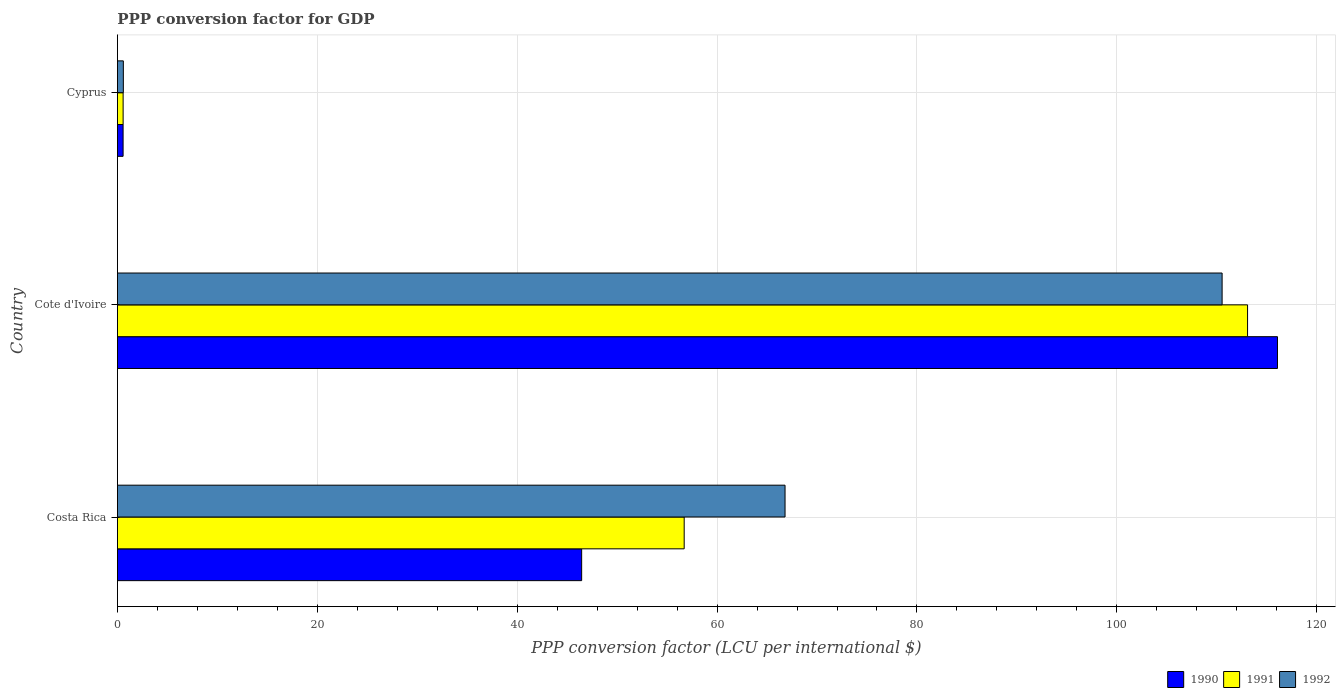Are the number of bars per tick equal to the number of legend labels?
Your answer should be very brief. Yes. How many bars are there on the 3rd tick from the top?
Keep it short and to the point. 3. How many bars are there on the 3rd tick from the bottom?
Your response must be concise. 3. What is the PPP conversion factor for GDP in 1990 in Cyprus?
Offer a terse response. 0.57. Across all countries, what is the maximum PPP conversion factor for GDP in 1992?
Ensure brevity in your answer.  110.53. Across all countries, what is the minimum PPP conversion factor for GDP in 1990?
Ensure brevity in your answer.  0.57. In which country was the PPP conversion factor for GDP in 1992 maximum?
Keep it short and to the point. Cote d'Ivoire. In which country was the PPP conversion factor for GDP in 1991 minimum?
Your answer should be very brief. Cyprus. What is the total PPP conversion factor for GDP in 1991 in the graph?
Offer a very short reply. 170.36. What is the difference between the PPP conversion factor for GDP in 1992 in Costa Rica and that in Cyprus?
Your answer should be compact. 66.21. What is the difference between the PPP conversion factor for GDP in 1991 in Cyprus and the PPP conversion factor for GDP in 1990 in Cote d'Ivoire?
Give a very brief answer. -115.5. What is the average PPP conversion factor for GDP in 1990 per country?
Keep it short and to the point. 54.36. What is the difference between the PPP conversion factor for GDP in 1992 and PPP conversion factor for GDP in 1991 in Cote d'Ivoire?
Make the answer very short. -2.55. What is the ratio of the PPP conversion factor for GDP in 1990 in Cote d'Ivoire to that in Cyprus?
Your answer should be very brief. 203.55. Is the PPP conversion factor for GDP in 1990 in Costa Rica less than that in Cyprus?
Your answer should be very brief. No. What is the difference between the highest and the second highest PPP conversion factor for GDP in 1991?
Your answer should be compact. 56.37. What is the difference between the highest and the lowest PPP conversion factor for GDP in 1992?
Make the answer very short. 109.94. Is the sum of the PPP conversion factor for GDP in 1991 in Cote d'Ivoire and Cyprus greater than the maximum PPP conversion factor for GDP in 1990 across all countries?
Your answer should be very brief. No. What does the 1st bar from the top in Costa Rica represents?
Your answer should be very brief. 1992. What does the 1st bar from the bottom in Costa Rica represents?
Offer a terse response. 1990. Are all the bars in the graph horizontal?
Your answer should be compact. Yes. How many countries are there in the graph?
Provide a short and direct response. 3. What is the difference between two consecutive major ticks on the X-axis?
Your answer should be compact. 20. Are the values on the major ticks of X-axis written in scientific E-notation?
Make the answer very short. No. Does the graph contain any zero values?
Ensure brevity in your answer.  No. Does the graph contain grids?
Offer a very short reply. Yes. How many legend labels are there?
Offer a terse response. 3. What is the title of the graph?
Your answer should be very brief. PPP conversion factor for GDP. What is the label or title of the X-axis?
Your response must be concise. PPP conversion factor (LCU per international $). What is the PPP conversion factor (LCU per international $) in 1990 in Costa Rica?
Your answer should be very brief. 46.45. What is the PPP conversion factor (LCU per international $) in 1991 in Costa Rica?
Keep it short and to the point. 56.71. What is the PPP conversion factor (LCU per international $) in 1992 in Costa Rica?
Offer a very short reply. 66.8. What is the PPP conversion factor (LCU per international $) in 1990 in Cote d'Ivoire?
Offer a terse response. 116.07. What is the PPP conversion factor (LCU per international $) of 1991 in Cote d'Ivoire?
Offer a terse response. 113.08. What is the PPP conversion factor (LCU per international $) of 1992 in Cote d'Ivoire?
Your answer should be compact. 110.53. What is the PPP conversion factor (LCU per international $) of 1990 in Cyprus?
Provide a succinct answer. 0.57. What is the PPP conversion factor (LCU per international $) of 1991 in Cyprus?
Offer a terse response. 0.57. What is the PPP conversion factor (LCU per international $) of 1992 in Cyprus?
Make the answer very short. 0.59. Across all countries, what is the maximum PPP conversion factor (LCU per international $) in 1990?
Keep it short and to the point. 116.07. Across all countries, what is the maximum PPP conversion factor (LCU per international $) of 1991?
Make the answer very short. 113.08. Across all countries, what is the maximum PPP conversion factor (LCU per international $) in 1992?
Ensure brevity in your answer.  110.53. Across all countries, what is the minimum PPP conversion factor (LCU per international $) of 1990?
Keep it short and to the point. 0.57. Across all countries, what is the minimum PPP conversion factor (LCU per international $) of 1991?
Offer a terse response. 0.57. Across all countries, what is the minimum PPP conversion factor (LCU per international $) of 1992?
Keep it short and to the point. 0.59. What is the total PPP conversion factor (LCU per international $) in 1990 in the graph?
Make the answer very short. 163.09. What is the total PPP conversion factor (LCU per international $) in 1991 in the graph?
Your answer should be compact. 170.36. What is the total PPP conversion factor (LCU per international $) in 1992 in the graph?
Provide a short and direct response. 177.93. What is the difference between the PPP conversion factor (LCU per international $) of 1990 in Costa Rica and that in Cote d'Ivoire?
Give a very brief answer. -69.62. What is the difference between the PPP conversion factor (LCU per international $) in 1991 in Costa Rica and that in Cote d'Ivoire?
Offer a terse response. -56.37. What is the difference between the PPP conversion factor (LCU per international $) in 1992 in Costa Rica and that in Cote d'Ivoire?
Make the answer very short. -43.73. What is the difference between the PPP conversion factor (LCU per international $) in 1990 in Costa Rica and that in Cyprus?
Offer a terse response. 45.88. What is the difference between the PPP conversion factor (LCU per international $) in 1991 in Costa Rica and that in Cyprus?
Provide a short and direct response. 56.14. What is the difference between the PPP conversion factor (LCU per international $) in 1992 in Costa Rica and that in Cyprus?
Your answer should be very brief. 66.21. What is the difference between the PPP conversion factor (LCU per international $) of 1990 in Cote d'Ivoire and that in Cyprus?
Provide a succinct answer. 115.5. What is the difference between the PPP conversion factor (LCU per international $) in 1991 in Cote d'Ivoire and that in Cyprus?
Offer a terse response. 112.5. What is the difference between the PPP conversion factor (LCU per international $) of 1992 in Cote d'Ivoire and that in Cyprus?
Your answer should be compact. 109.94. What is the difference between the PPP conversion factor (LCU per international $) in 1990 in Costa Rica and the PPP conversion factor (LCU per international $) in 1991 in Cote d'Ivoire?
Give a very brief answer. -66.63. What is the difference between the PPP conversion factor (LCU per international $) in 1990 in Costa Rica and the PPP conversion factor (LCU per international $) in 1992 in Cote d'Ivoire?
Provide a succinct answer. -64.08. What is the difference between the PPP conversion factor (LCU per international $) in 1991 in Costa Rica and the PPP conversion factor (LCU per international $) in 1992 in Cote d'Ivoire?
Your answer should be compact. -53.82. What is the difference between the PPP conversion factor (LCU per international $) in 1990 in Costa Rica and the PPP conversion factor (LCU per international $) in 1991 in Cyprus?
Ensure brevity in your answer.  45.88. What is the difference between the PPP conversion factor (LCU per international $) of 1990 in Costa Rica and the PPP conversion factor (LCU per international $) of 1992 in Cyprus?
Give a very brief answer. 45.86. What is the difference between the PPP conversion factor (LCU per international $) of 1991 in Costa Rica and the PPP conversion factor (LCU per international $) of 1992 in Cyprus?
Your answer should be compact. 56.11. What is the difference between the PPP conversion factor (LCU per international $) of 1990 in Cote d'Ivoire and the PPP conversion factor (LCU per international $) of 1991 in Cyprus?
Ensure brevity in your answer.  115.5. What is the difference between the PPP conversion factor (LCU per international $) of 1990 in Cote d'Ivoire and the PPP conversion factor (LCU per international $) of 1992 in Cyprus?
Your answer should be compact. 115.48. What is the difference between the PPP conversion factor (LCU per international $) in 1991 in Cote d'Ivoire and the PPP conversion factor (LCU per international $) in 1992 in Cyprus?
Ensure brevity in your answer.  112.48. What is the average PPP conversion factor (LCU per international $) of 1990 per country?
Give a very brief answer. 54.36. What is the average PPP conversion factor (LCU per international $) of 1991 per country?
Your answer should be compact. 56.79. What is the average PPP conversion factor (LCU per international $) in 1992 per country?
Give a very brief answer. 59.31. What is the difference between the PPP conversion factor (LCU per international $) of 1990 and PPP conversion factor (LCU per international $) of 1991 in Costa Rica?
Make the answer very short. -10.26. What is the difference between the PPP conversion factor (LCU per international $) of 1990 and PPP conversion factor (LCU per international $) of 1992 in Costa Rica?
Give a very brief answer. -20.35. What is the difference between the PPP conversion factor (LCU per international $) in 1991 and PPP conversion factor (LCU per international $) in 1992 in Costa Rica?
Your response must be concise. -10.09. What is the difference between the PPP conversion factor (LCU per international $) of 1990 and PPP conversion factor (LCU per international $) of 1991 in Cote d'Ivoire?
Provide a short and direct response. 2.99. What is the difference between the PPP conversion factor (LCU per international $) of 1990 and PPP conversion factor (LCU per international $) of 1992 in Cote d'Ivoire?
Make the answer very short. 5.54. What is the difference between the PPP conversion factor (LCU per international $) in 1991 and PPP conversion factor (LCU per international $) in 1992 in Cote d'Ivoire?
Give a very brief answer. 2.55. What is the difference between the PPP conversion factor (LCU per international $) in 1990 and PPP conversion factor (LCU per international $) in 1991 in Cyprus?
Your answer should be compact. -0. What is the difference between the PPP conversion factor (LCU per international $) in 1990 and PPP conversion factor (LCU per international $) in 1992 in Cyprus?
Give a very brief answer. -0.02. What is the difference between the PPP conversion factor (LCU per international $) in 1991 and PPP conversion factor (LCU per international $) in 1992 in Cyprus?
Provide a succinct answer. -0.02. What is the ratio of the PPP conversion factor (LCU per international $) in 1990 in Costa Rica to that in Cote d'Ivoire?
Keep it short and to the point. 0.4. What is the ratio of the PPP conversion factor (LCU per international $) in 1991 in Costa Rica to that in Cote d'Ivoire?
Keep it short and to the point. 0.5. What is the ratio of the PPP conversion factor (LCU per international $) of 1992 in Costa Rica to that in Cote d'Ivoire?
Your answer should be compact. 0.6. What is the ratio of the PPP conversion factor (LCU per international $) in 1990 in Costa Rica to that in Cyprus?
Make the answer very short. 81.46. What is the ratio of the PPP conversion factor (LCU per international $) of 1991 in Costa Rica to that in Cyprus?
Make the answer very short. 98.91. What is the ratio of the PPP conversion factor (LCU per international $) in 1992 in Costa Rica to that in Cyprus?
Your response must be concise. 112.38. What is the ratio of the PPP conversion factor (LCU per international $) in 1990 in Cote d'Ivoire to that in Cyprus?
Keep it short and to the point. 203.55. What is the ratio of the PPP conversion factor (LCU per international $) of 1991 in Cote d'Ivoire to that in Cyprus?
Your answer should be compact. 197.23. What is the ratio of the PPP conversion factor (LCU per international $) of 1992 in Cote d'Ivoire to that in Cyprus?
Offer a terse response. 185.95. What is the difference between the highest and the second highest PPP conversion factor (LCU per international $) in 1990?
Provide a succinct answer. 69.62. What is the difference between the highest and the second highest PPP conversion factor (LCU per international $) of 1991?
Provide a succinct answer. 56.37. What is the difference between the highest and the second highest PPP conversion factor (LCU per international $) of 1992?
Provide a succinct answer. 43.73. What is the difference between the highest and the lowest PPP conversion factor (LCU per international $) in 1990?
Your answer should be compact. 115.5. What is the difference between the highest and the lowest PPP conversion factor (LCU per international $) in 1991?
Keep it short and to the point. 112.5. What is the difference between the highest and the lowest PPP conversion factor (LCU per international $) of 1992?
Provide a succinct answer. 109.94. 